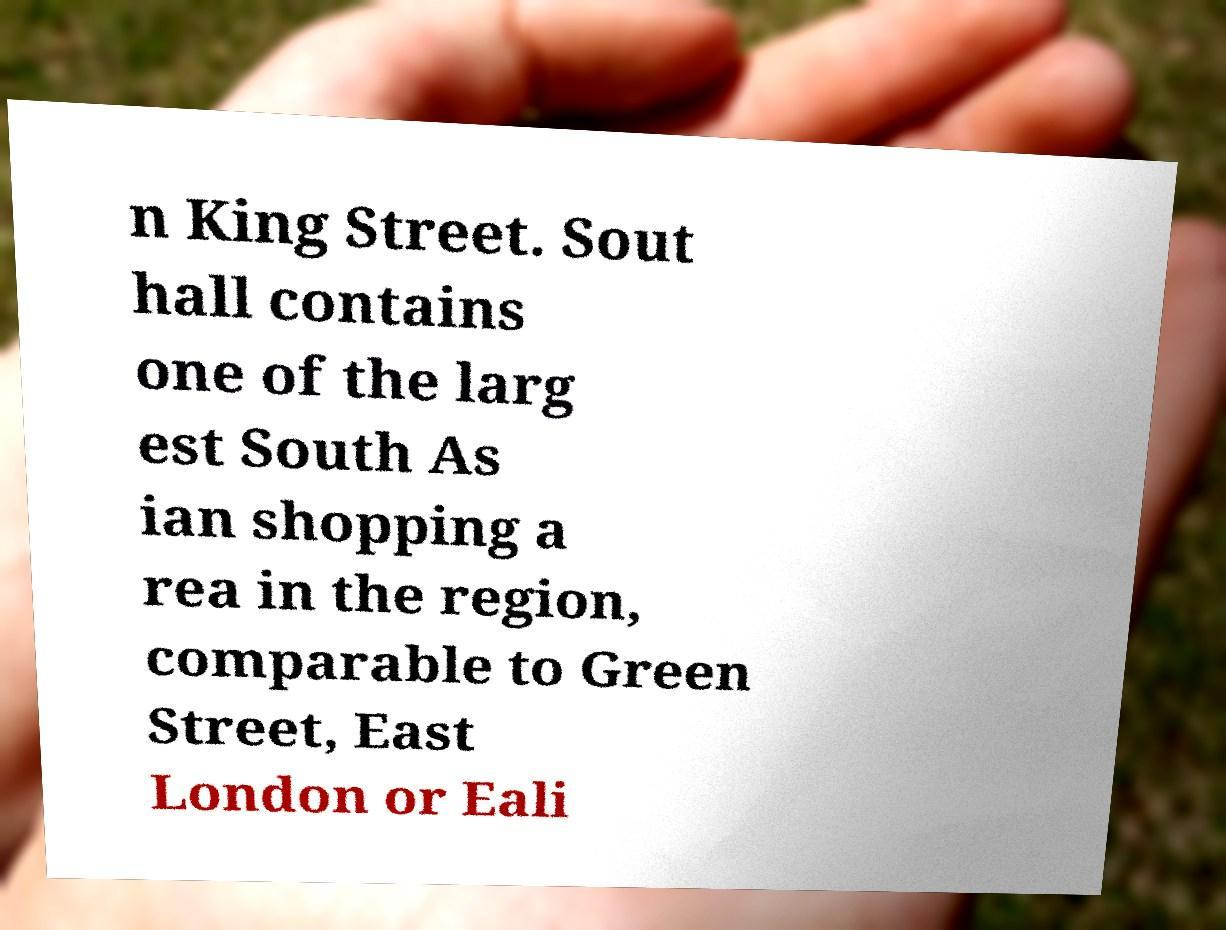Could you extract and type out the text from this image? n King Street. Sout hall contains one of the larg est South As ian shopping a rea in the region, comparable to Green Street, East London or Eali 